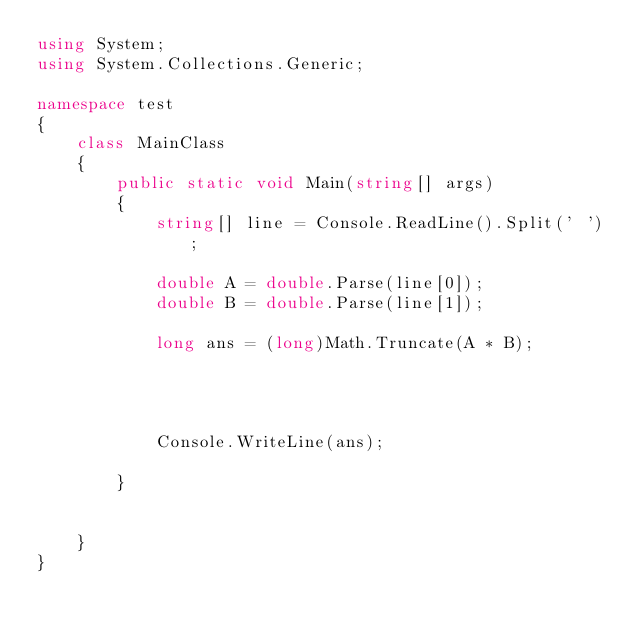<code> <loc_0><loc_0><loc_500><loc_500><_C#_>using System;
using System.Collections.Generic;

namespace test
{
    class MainClass
    {
        public static void Main(string[] args)
        {
            string[] line = Console.ReadLine().Split(' ');

            double A = double.Parse(line[0]);
            double B = double.Parse(line[1]);

            long ans = (long)Math.Truncate(A * B);

           


            Console.WriteLine(ans);

        }


    }
}
</code> 